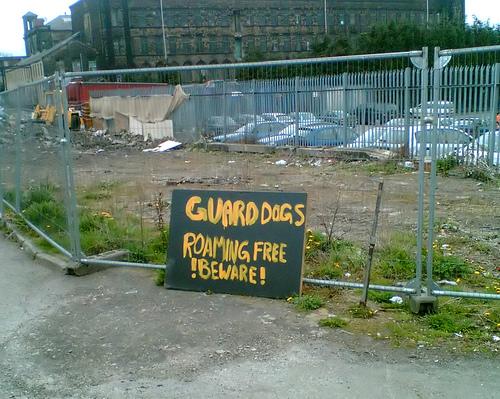What are roaming free?
Quick response, please. Guard dogs. What color is the question written in?
Answer briefly. Yellow. Are the cars parked?
Quick response, please. Yes. 